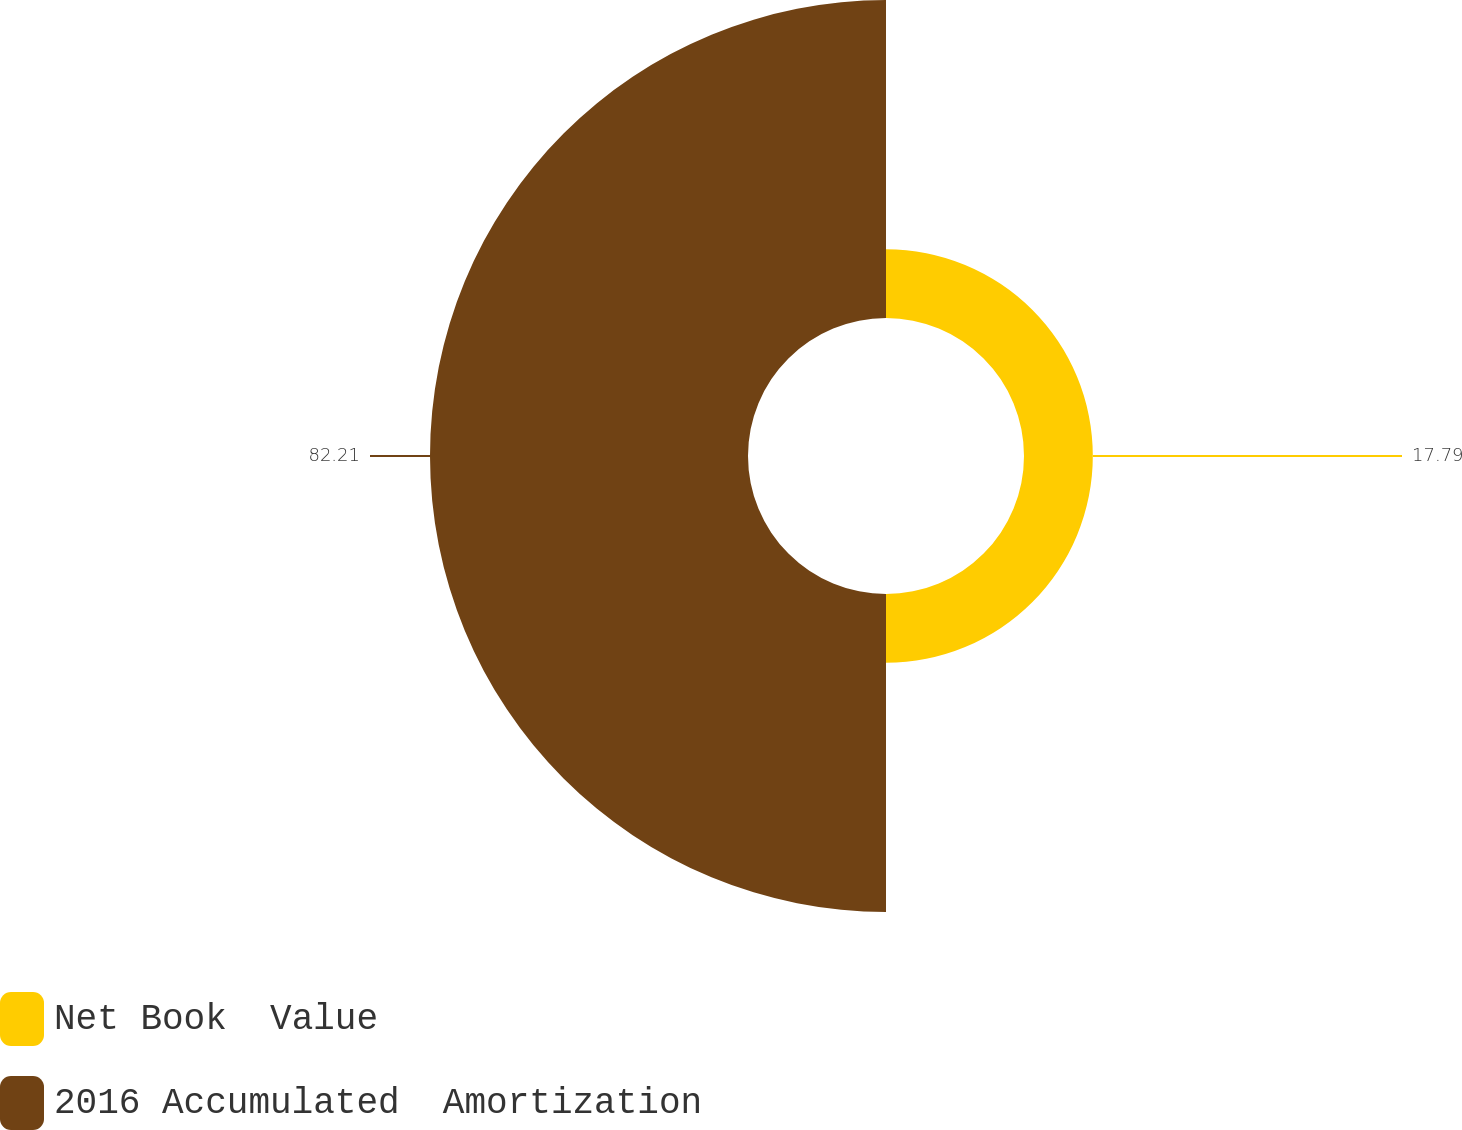<chart> <loc_0><loc_0><loc_500><loc_500><pie_chart><fcel>Net Book  Value<fcel>2016 Accumulated  Amortization<nl><fcel>17.79%<fcel>82.21%<nl></chart> 